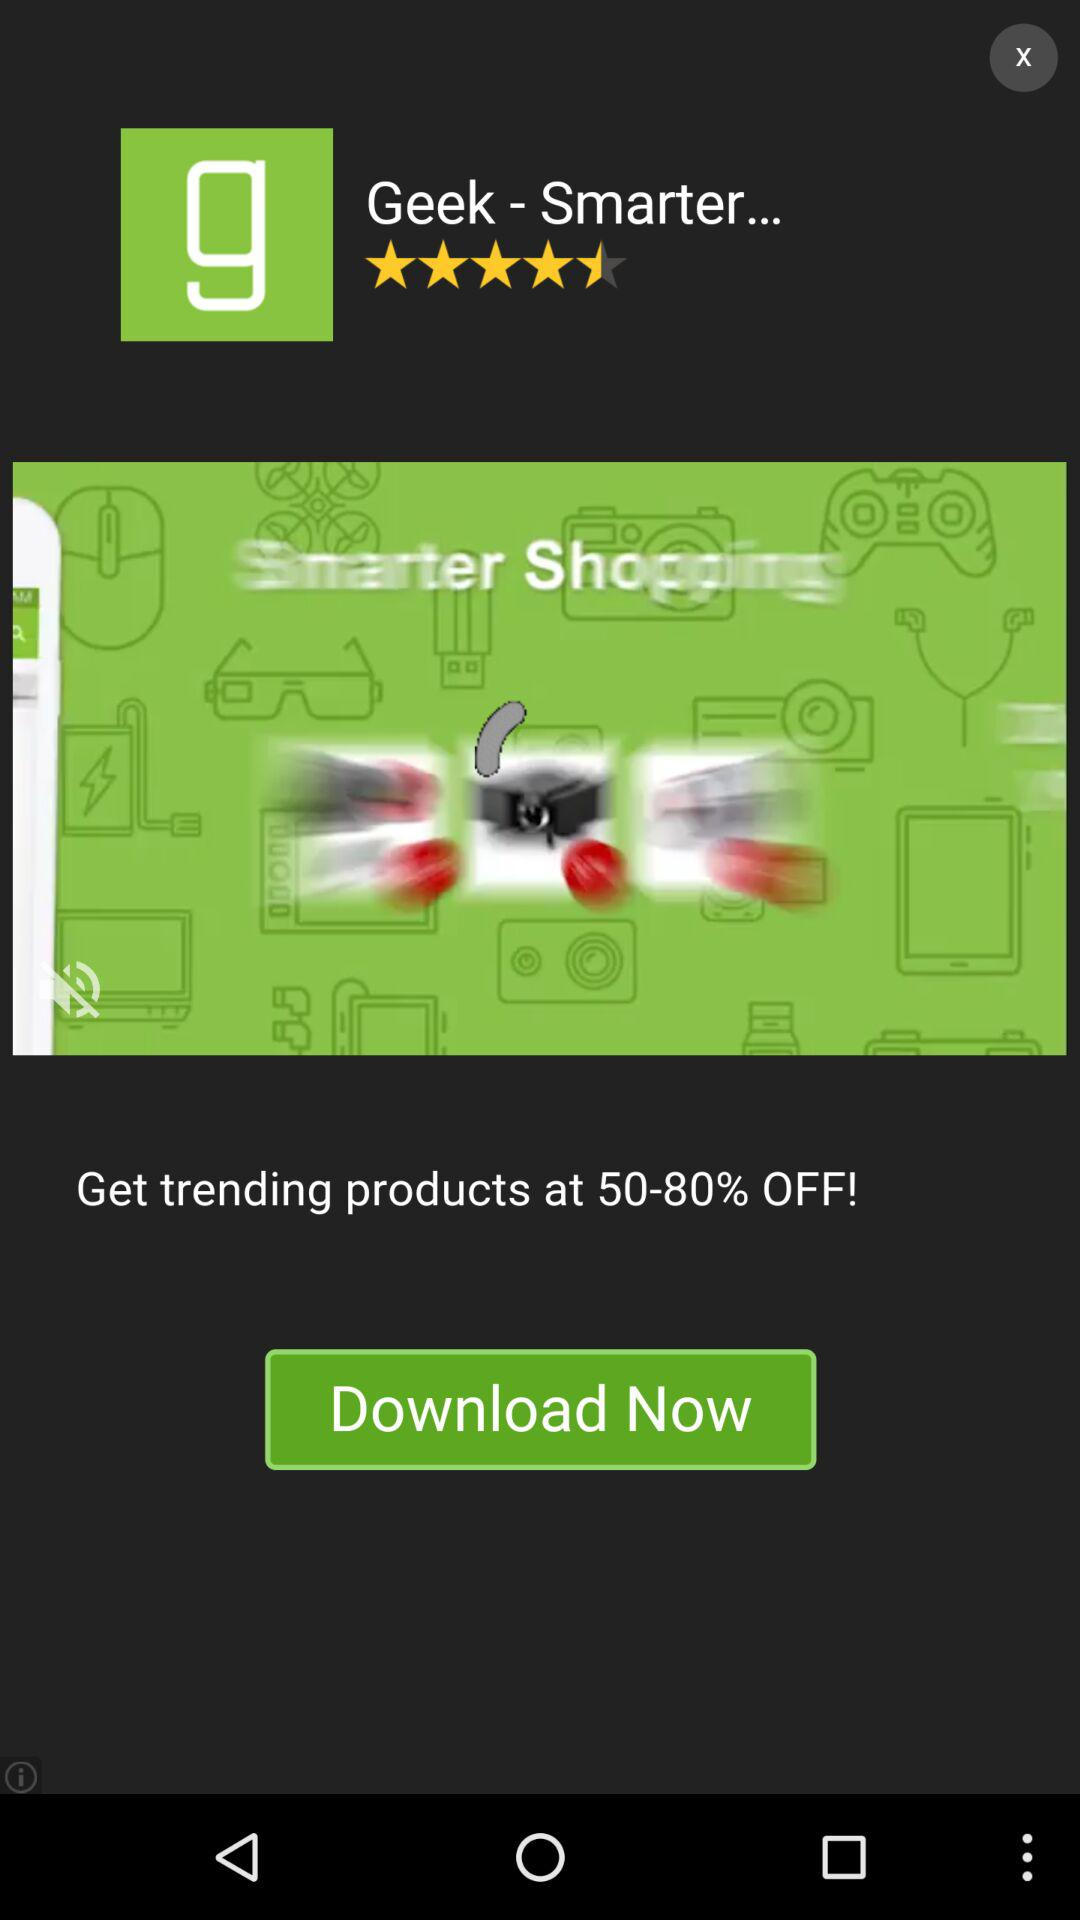What is the rating for "Geek - Smarter..."? The rating is 4.5 stars. 